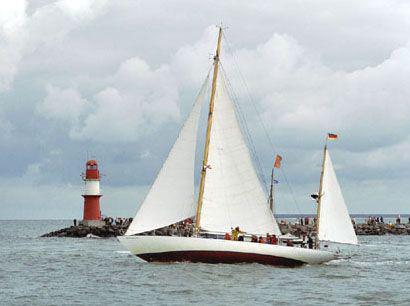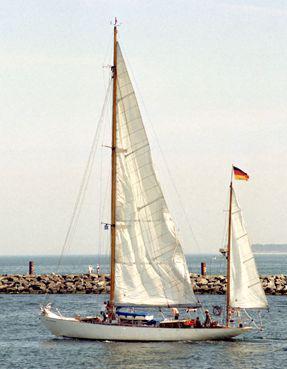The first image is the image on the left, the second image is the image on the right. Considering the images on both sides, is "there are puffy clouds in one of the images" valid? Answer yes or no. Yes. The first image is the image on the left, the second image is the image on the right. Given the left and right images, does the statement "Trees can be seen in the background in one  of the images." hold true? Answer yes or no. No. 